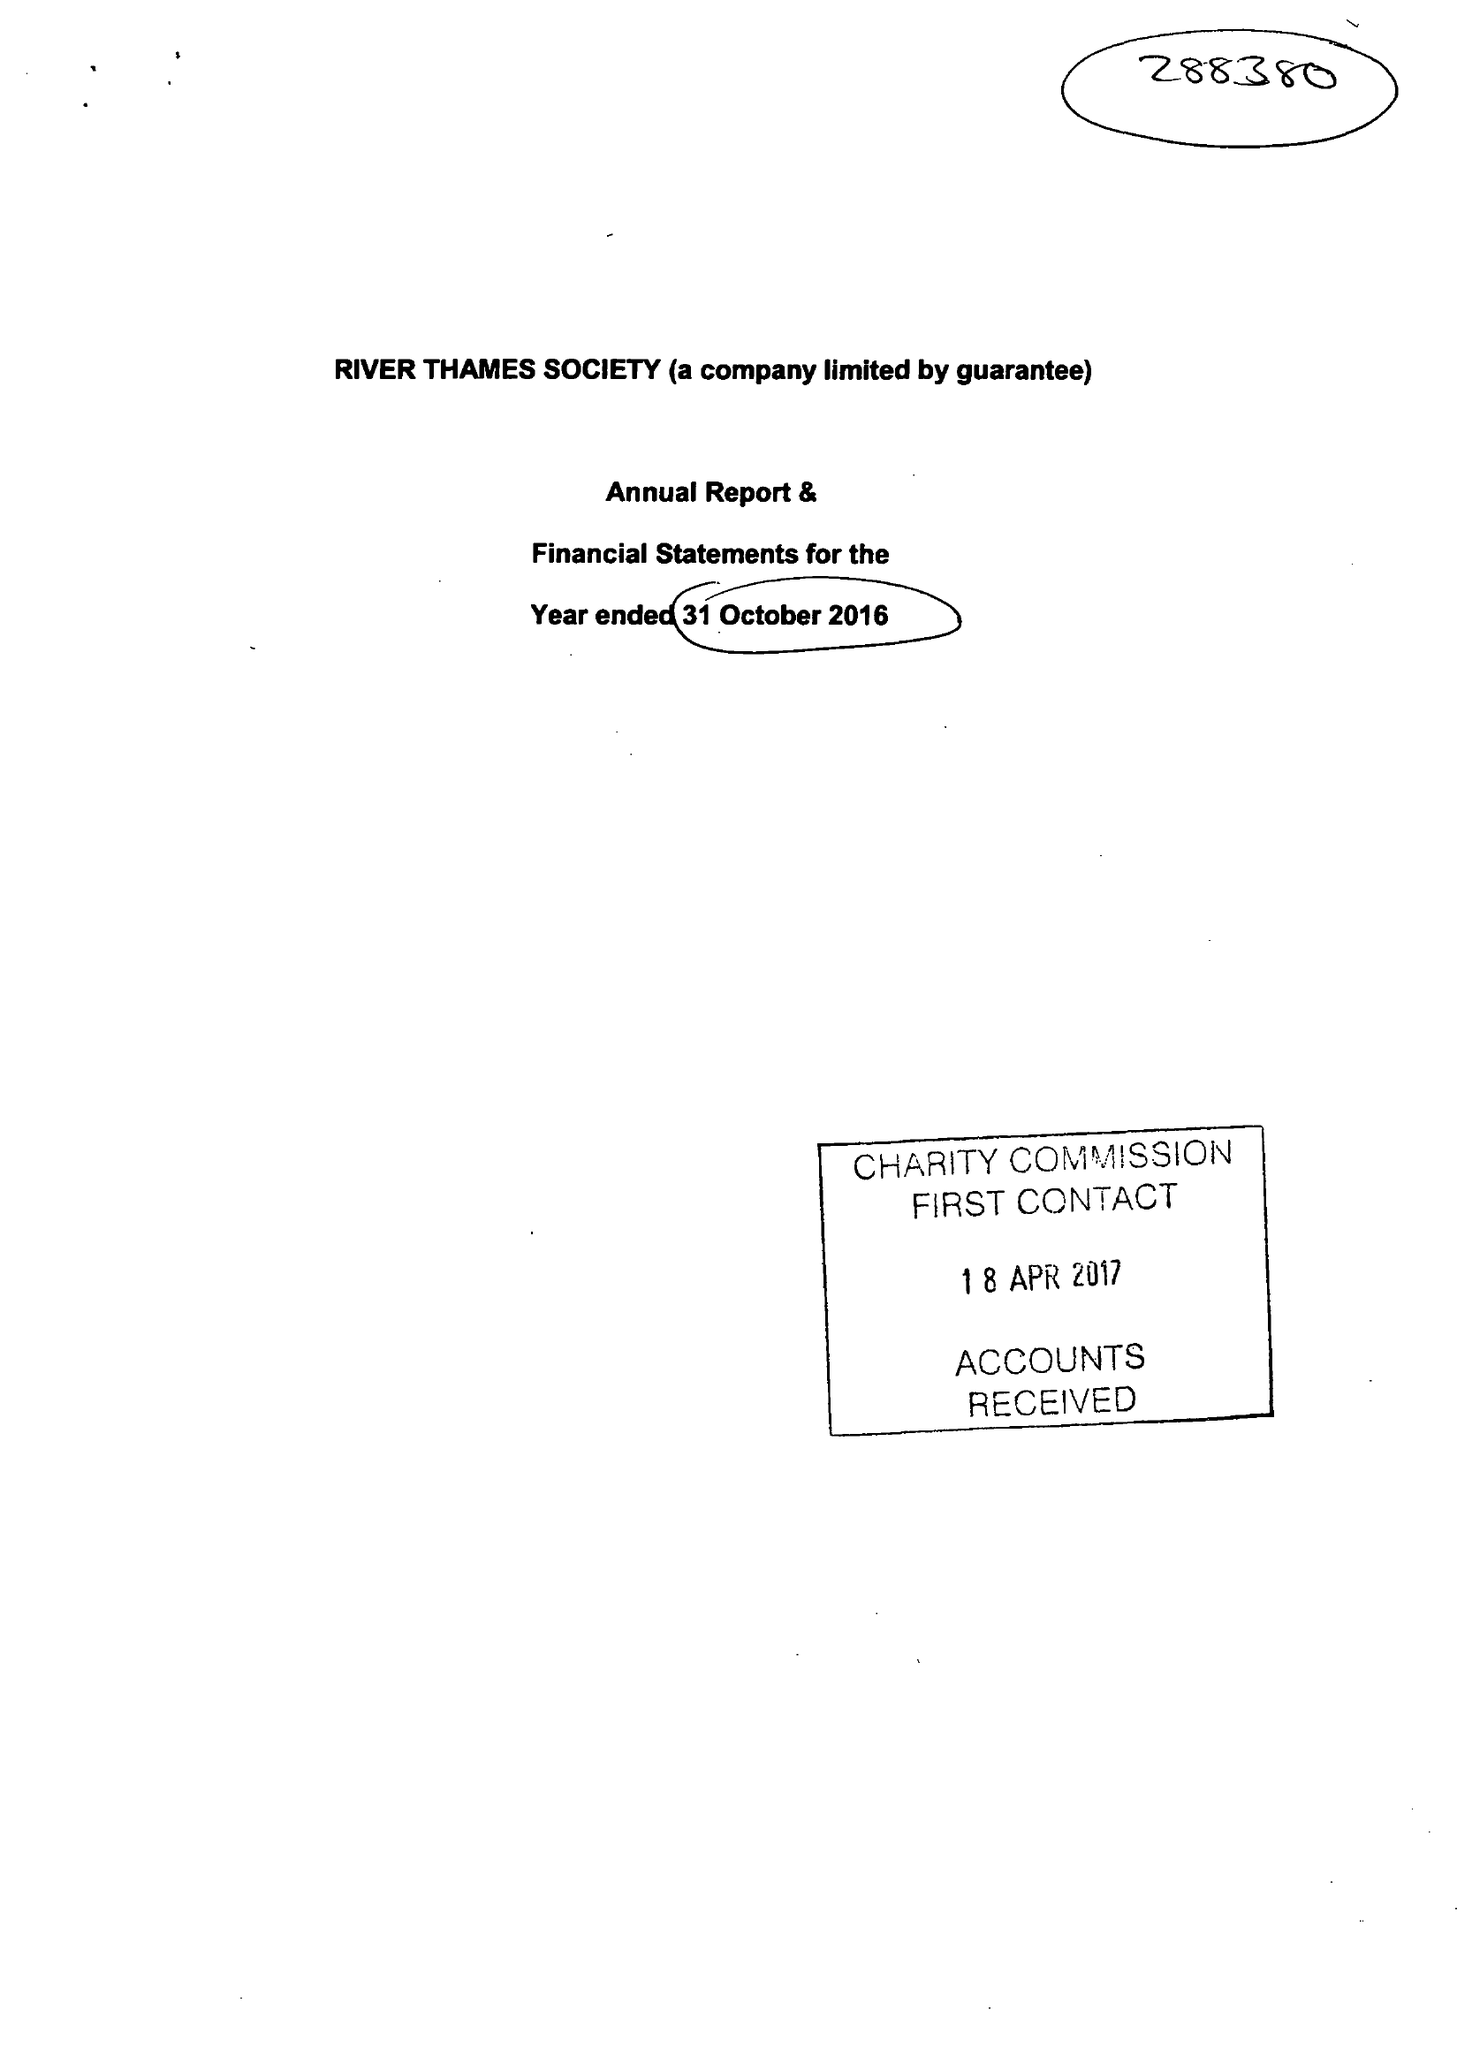What is the value for the charity_number?
Answer the question using a single word or phrase. 288380 